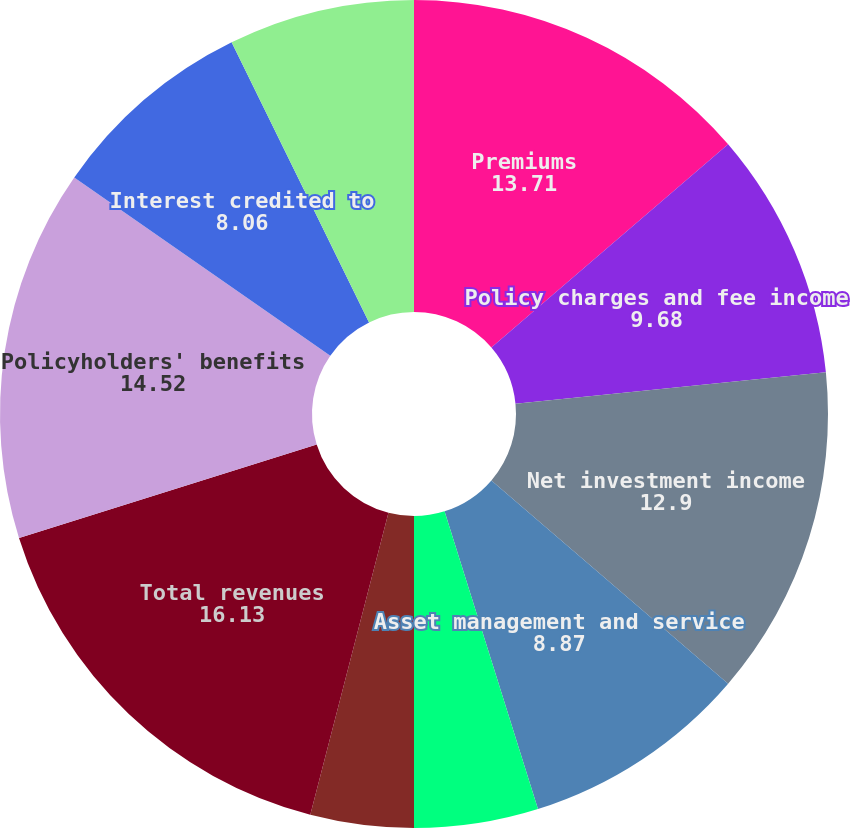Convert chart to OTSL. <chart><loc_0><loc_0><loc_500><loc_500><pie_chart><fcel>Premiums<fcel>Policy charges and fee income<fcel>Net investment income<fcel>Asset management and service<fcel>Other income (loss)<fcel>Realized investment gains<fcel>Total revenues<fcel>Policyholders' benefits<fcel>Interest credited to<fcel>Dividends to policyholders<nl><fcel>13.71%<fcel>9.68%<fcel>12.9%<fcel>8.87%<fcel>4.84%<fcel>4.03%<fcel>16.13%<fcel>14.52%<fcel>8.06%<fcel>7.26%<nl></chart> 